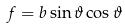<formula> <loc_0><loc_0><loc_500><loc_500>f = b \sin \vartheta \cos \vartheta</formula> 